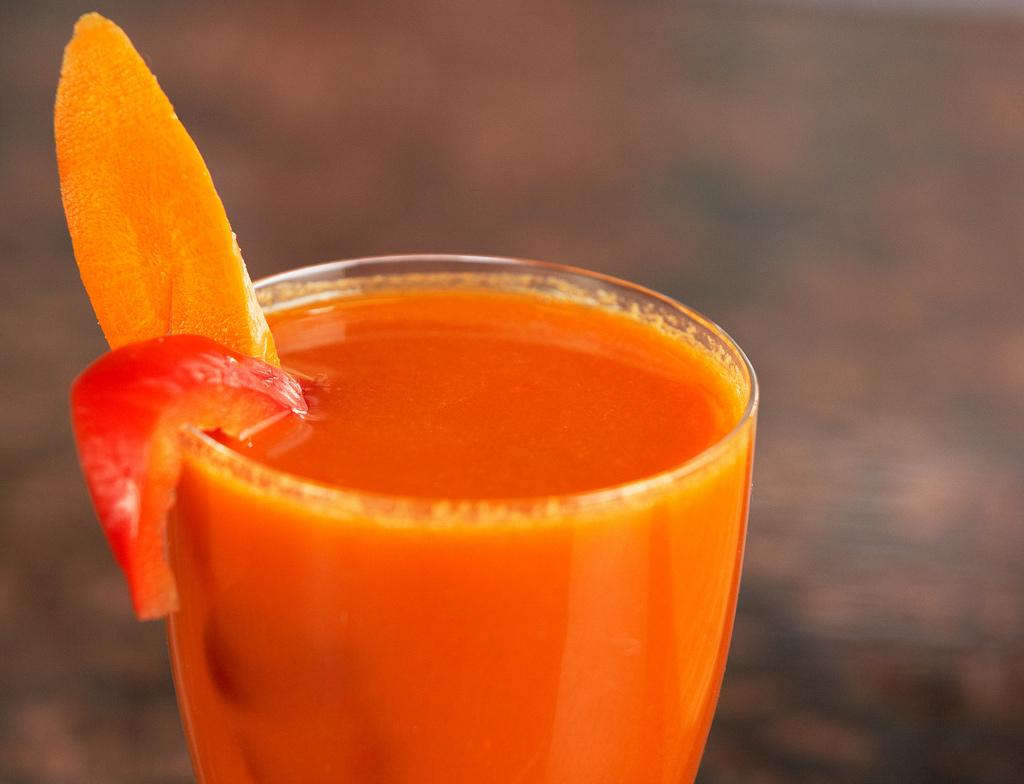What is inside the glass that is visible in the image? There is a glass with liquid in the image, and vegetable slices are in the glass. What can be seen in the background of the image? The background of the image is blurred. Who is the boy that can be heard talking in the image? There is no boy present in the image, nor is there any sound or talking. 